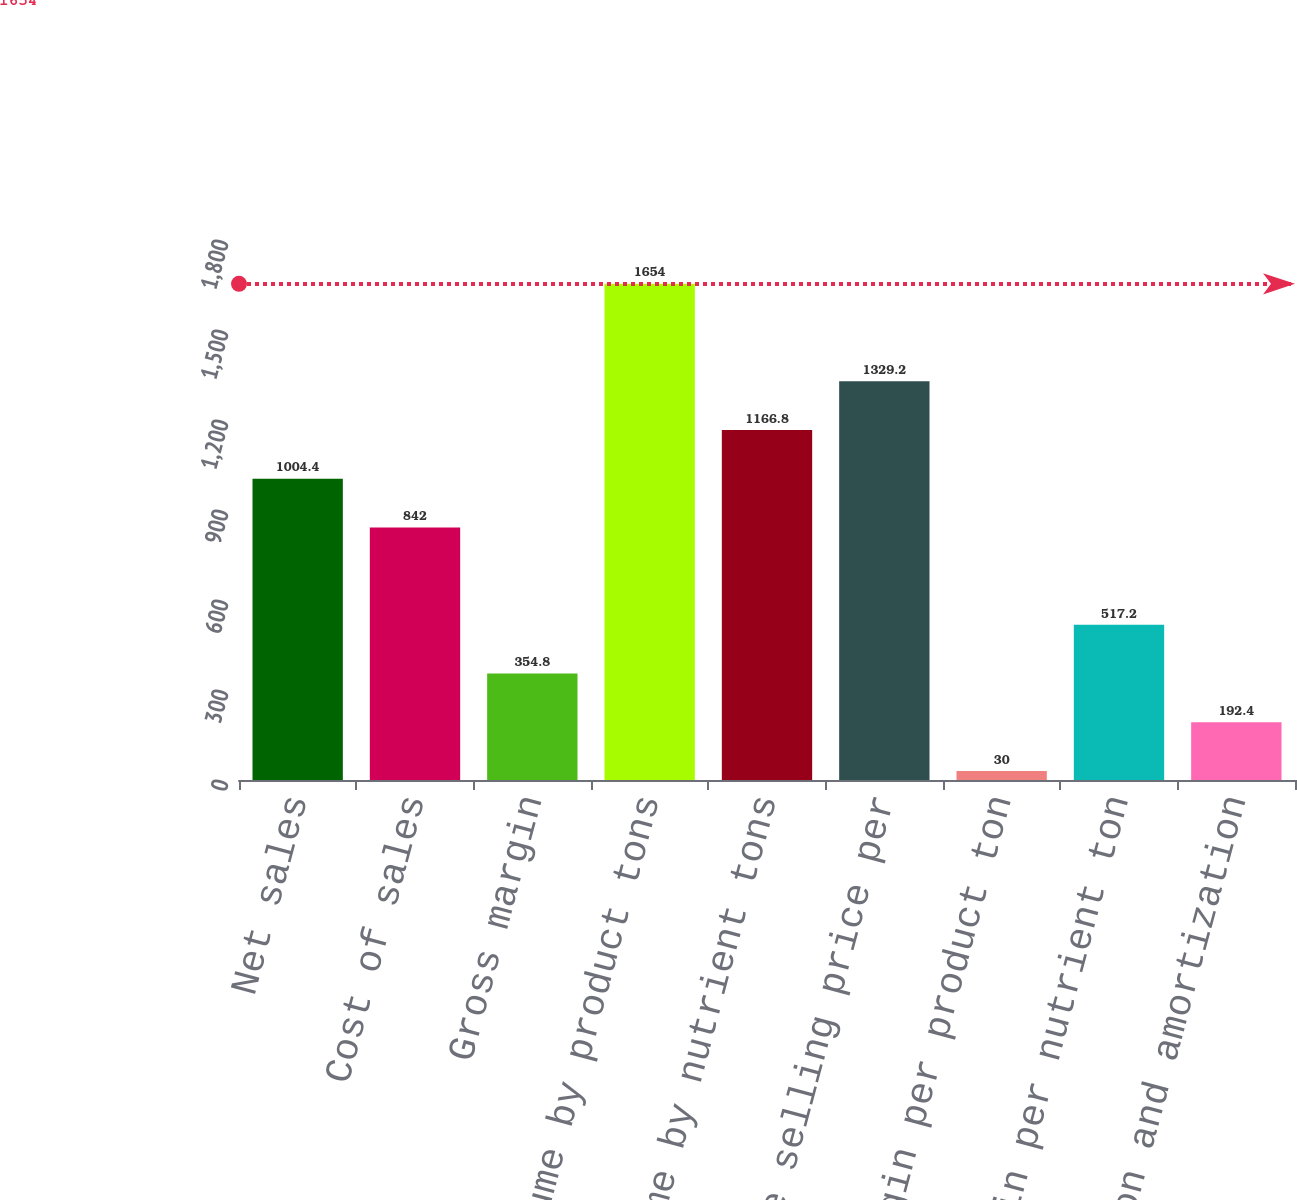Convert chart to OTSL. <chart><loc_0><loc_0><loc_500><loc_500><bar_chart><fcel>Net sales<fcel>Cost of sales<fcel>Gross margin<fcel>Sales volume by product tons<fcel>Sales volume by nutrient tons<fcel>Average selling price per<fcel>Gross margin per product ton<fcel>Gross margin per nutrient ton<fcel>Depreciation and amortization<nl><fcel>1004.4<fcel>842<fcel>354.8<fcel>1654<fcel>1166.8<fcel>1329.2<fcel>30<fcel>517.2<fcel>192.4<nl></chart> 